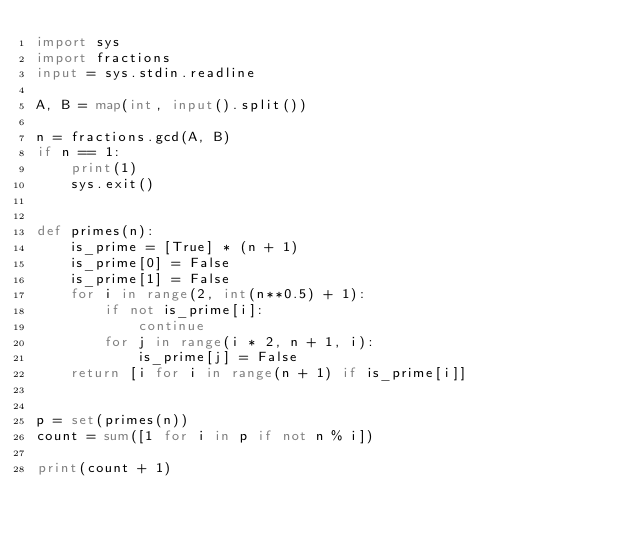<code> <loc_0><loc_0><loc_500><loc_500><_Python_>import sys
import fractions
input = sys.stdin.readline

A, B = map(int, input().split())

n = fractions.gcd(A, B)
if n == 1:
    print(1)
    sys.exit()


def primes(n):
    is_prime = [True] * (n + 1)
    is_prime[0] = False
    is_prime[1] = False
    for i in range(2, int(n**0.5) + 1):
        if not is_prime[i]:
            continue
        for j in range(i * 2, n + 1, i):
            is_prime[j] = False
    return [i for i in range(n + 1) if is_prime[i]]


p = set(primes(n))
count = sum([1 for i in p if not n % i])

print(count + 1)
</code> 